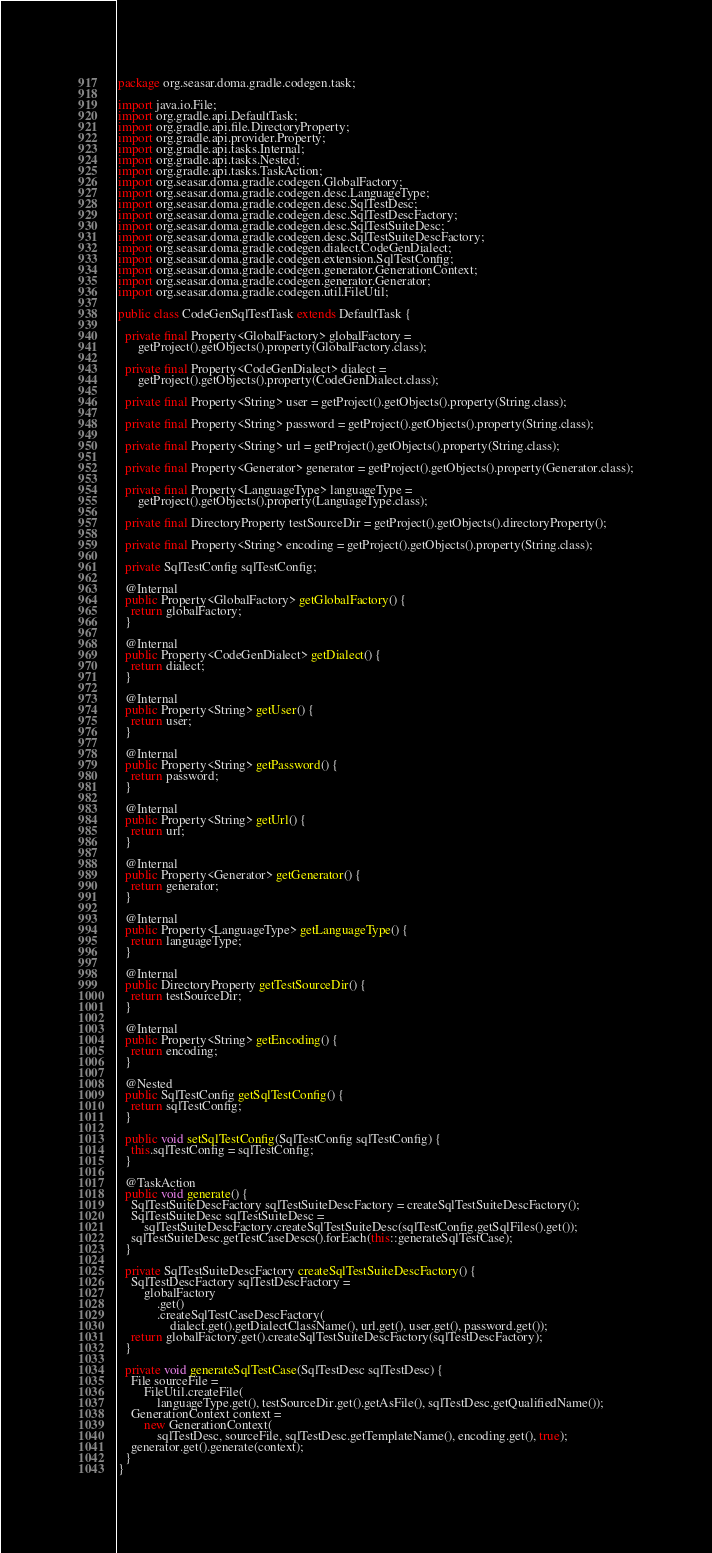Convert code to text. <code><loc_0><loc_0><loc_500><loc_500><_Java_>package org.seasar.doma.gradle.codegen.task;

import java.io.File;
import org.gradle.api.DefaultTask;
import org.gradle.api.file.DirectoryProperty;
import org.gradle.api.provider.Property;
import org.gradle.api.tasks.Internal;
import org.gradle.api.tasks.Nested;
import org.gradle.api.tasks.TaskAction;
import org.seasar.doma.gradle.codegen.GlobalFactory;
import org.seasar.doma.gradle.codegen.desc.LanguageType;
import org.seasar.doma.gradle.codegen.desc.SqlTestDesc;
import org.seasar.doma.gradle.codegen.desc.SqlTestDescFactory;
import org.seasar.doma.gradle.codegen.desc.SqlTestSuiteDesc;
import org.seasar.doma.gradle.codegen.desc.SqlTestSuiteDescFactory;
import org.seasar.doma.gradle.codegen.dialect.CodeGenDialect;
import org.seasar.doma.gradle.codegen.extension.SqlTestConfig;
import org.seasar.doma.gradle.codegen.generator.GenerationContext;
import org.seasar.doma.gradle.codegen.generator.Generator;
import org.seasar.doma.gradle.codegen.util.FileUtil;

public class CodeGenSqlTestTask extends DefaultTask {

  private final Property<GlobalFactory> globalFactory =
      getProject().getObjects().property(GlobalFactory.class);

  private final Property<CodeGenDialect> dialect =
      getProject().getObjects().property(CodeGenDialect.class);

  private final Property<String> user = getProject().getObjects().property(String.class);

  private final Property<String> password = getProject().getObjects().property(String.class);

  private final Property<String> url = getProject().getObjects().property(String.class);

  private final Property<Generator> generator = getProject().getObjects().property(Generator.class);

  private final Property<LanguageType> languageType =
      getProject().getObjects().property(LanguageType.class);

  private final DirectoryProperty testSourceDir = getProject().getObjects().directoryProperty();

  private final Property<String> encoding = getProject().getObjects().property(String.class);

  private SqlTestConfig sqlTestConfig;

  @Internal
  public Property<GlobalFactory> getGlobalFactory() {
    return globalFactory;
  }

  @Internal
  public Property<CodeGenDialect> getDialect() {
    return dialect;
  }

  @Internal
  public Property<String> getUser() {
    return user;
  }

  @Internal
  public Property<String> getPassword() {
    return password;
  }

  @Internal
  public Property<String> getUrl() {
    return url;
  }

  @Internal
  public Property<Generator> getGenerator() {
    return generator;
  }

  @Internal
  public Property<LanguageType> getLanguageType() {
    return languageType;
  }

  @Internal
  public DirectoryProperty getTestSourceDir() {
    return testSourceDir;
  }

  @Internal
  public Property<String> getEncoding() {
    return encoding;
  }

  @Nested
  public SqlTestConfig getSqlTestConfig() {
    return sqlTestConfig;
  }

  public void setSqlTestConfig(SqlTestConfig sqlTestConfig) {
    this.sqlTestConfig = sqlTestConfig;
  }

  @TaskAction
  public void generate() {
    SqlTestSuiteDescFactory sqlTestSuiteDescFactory = createSqlTestSuiteDescFactory();
    SqlTestSuiteDesc sqlTestSuiteDesc =
        sqlTestSuiteDescFactory.createSqlTestSuiteDesc(sqlTestConfig.getSqlFiles().get());
    sqlTestSuiteDesc.getTestCaseDescs().forEach(this::generateSqlTestCase);
  }

  private SqlTestSuiteDescFactory createSqlTestSuiteDescFactory() {
    SqlTestDescFactory sqlTestDescFactory =
        globalFactory
            .get()
            .createSqlTestCaseDescFactory(
                dialect.get().getDialectClassName(), url.get(), user.get(), password.get());
    return globalFactory.get().createSqlTestSuiteDescFactory(sqlTestDescFactory);
  }

  private void generateSqlTestCase(SqlTestDesc sqlTestDesc) {
    File sourceFile =
        FileUtil.createFile(
            languageType.get(), testSourceDir.get().getAsFile(), sqlTestDesc.getQualifiedName());
    GenerationContext context =
        new GenerationContext(
            sqlTestDesc, sourceFile, sqlTestDesc.getTemplateName(), encoding.get(), true);
    generator.get().generate(context);
  }
}
</code> 